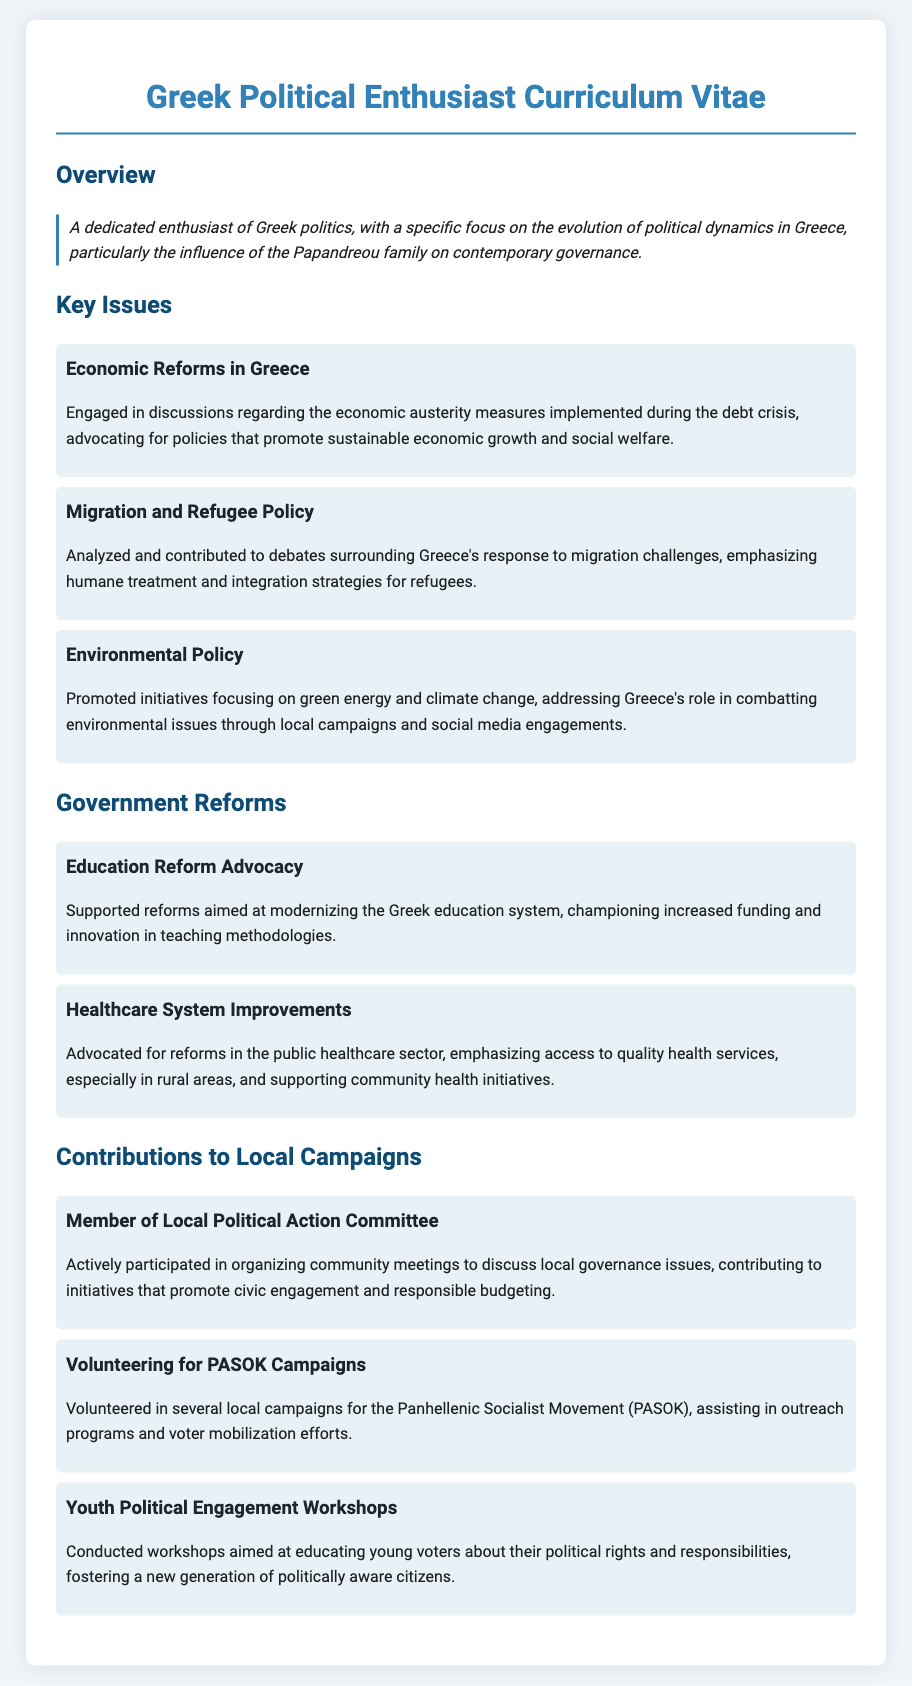What is the main focus of the CV? The CV emphasizes the individual's enthusiasm for Greek politics and the Papandreou family's influence on governance.
Answer: Influence of the Papandreou family What economic issue is discussed? The CV mentions discussions about sustainable economic growth and social welfare during the debt crisis.
Answer: Economic austerity measures How many government reforms are listed in the CV? There are two government reforms mentioned in the document.
Answer: Two Which local political movement is mentioned in the contributions? The CV references the individual’s volunteer work with the Panhellenic Socialist Movement (PASOK).
Answer: PASOK What type of workshops did the individual conduct? The individual conducted workshops focused on educating young voters about their political rights and responsibilities.
Answer: Youth Political Engagement Workshops What environmental initiative is promoted in the key issues? The CV highlights initiatives focusing on green energy and climate change.
Answer: Green energy and climate change What is the role of the individual in the Local Political Action Committee? The individual is a member who organizes community meetings to discuss local governance issues.
Answer: Member What healthcare issue is addressed? The CV addresses public healthcare sector reforms for access to quality services in rural areas.
Answer: Healthcare System Improvements 